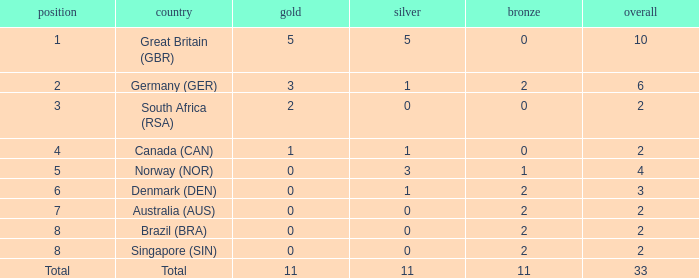What is the total when the nation is brazil (bra) and bronze is more than 2? None. 